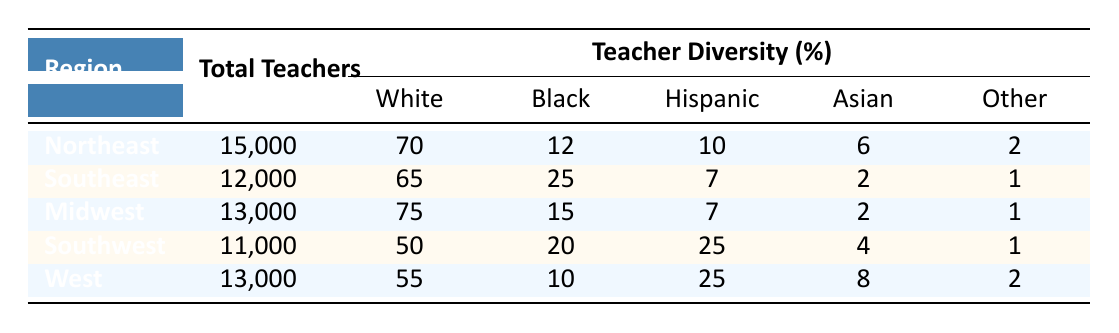What is the total number of teachers in the Southeast region? The table lists the total number of teachers in the Southeast region as 12,000.
Answer: 12,000 Which region has the highest percentage of Black teachers? The table shows that the Southeast region has the highest percentage of Black teachers at 25%.
Answer: Southeast What percentage of teachers in the Southwest region are Hispanic? The table indicates that 25% of teachers in the Southwest region are Hispanic.
Answer: 25% What is the percentage difference of White teachers between the Northeast and Midwest regions? The Northeast has 70% White teachers and the Midwest has 75%. The difference is 75% - 70% = 5%.
Answer: 5% True or False: The West region has more teachers than the Northeast region. The table lists 13,000 teachers in the West and 15,000 in the Northeast, showing that the West has fewer teachers.
Answer: False How many total teachers are there across all regions combined? To find the total, sum the total teachers in each region: 15,000 + 12,000 + 13,000 + 11,000 + 13,000 = 64,000.
Answer: 64,000 Which region shows the lowest percentage of White teachers, and what is that percentage? The Southwest region shows the lowest percentage of White teachers at 50%.
Answer: Southwest, 50% If we compare the Asian teacher percentages between the Northeast and the West, what is the difference? The Northeast has 6% Asian teachers, and the West has 8%. The difference is 8% - 6% = 2%.
Answer: 2% What is the average percentage of Black teachers across all regions? The percentages of Black teachers are 12%, 25%, 15%, 20%, and 10%. The average is (12 + 25 + 15 + 20 + 10) / 5 = 18.4%.
Answer: 18.4% In which region is the percentage of Asian teachers higher than the percentage of Black teachers? In the West region, the percentage of Asian teachers is 8%, while Black teachers are at 10%, so it does not exceed. However, the Northeast has a 6% Asian percentage compared to 12% Black, which also does not exceed; confirming only the data in Southwest with 4% Asian compared to 20% Black, does not exceed. So, no region.
Answer: No regions exceed 